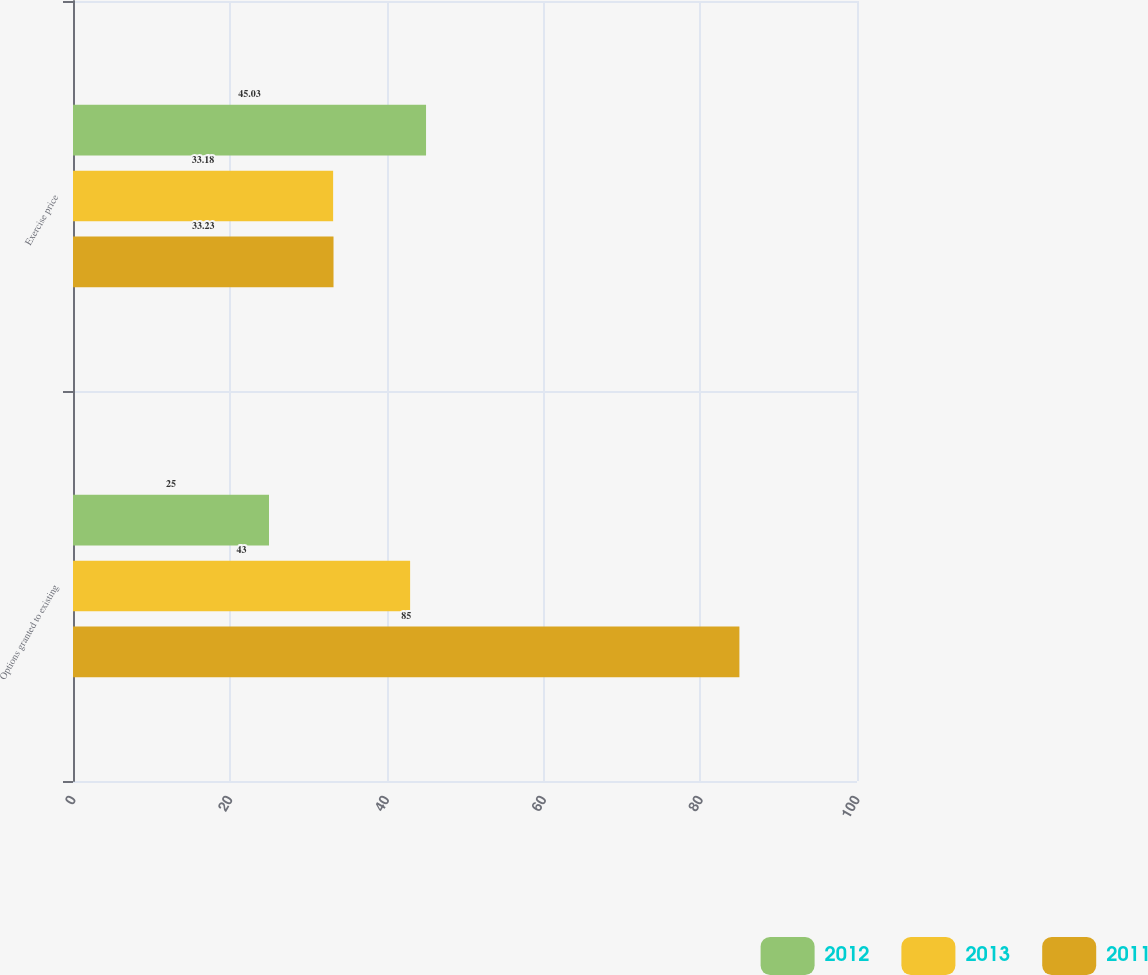Convert chart to OTSL. <chart><loc_0><loc_0><loc_500><loc_500><stacked_bar_chart><ecel><fcel>Options granted to existing<fcel>Exercise price<nl><fcel>2012<fcel>25<fcel>45.03<nl><fcel>2013<fcel>43<fcel>33.18<nl><fcel>2011<fcel>85<fcel>33.23<nl></chart> 